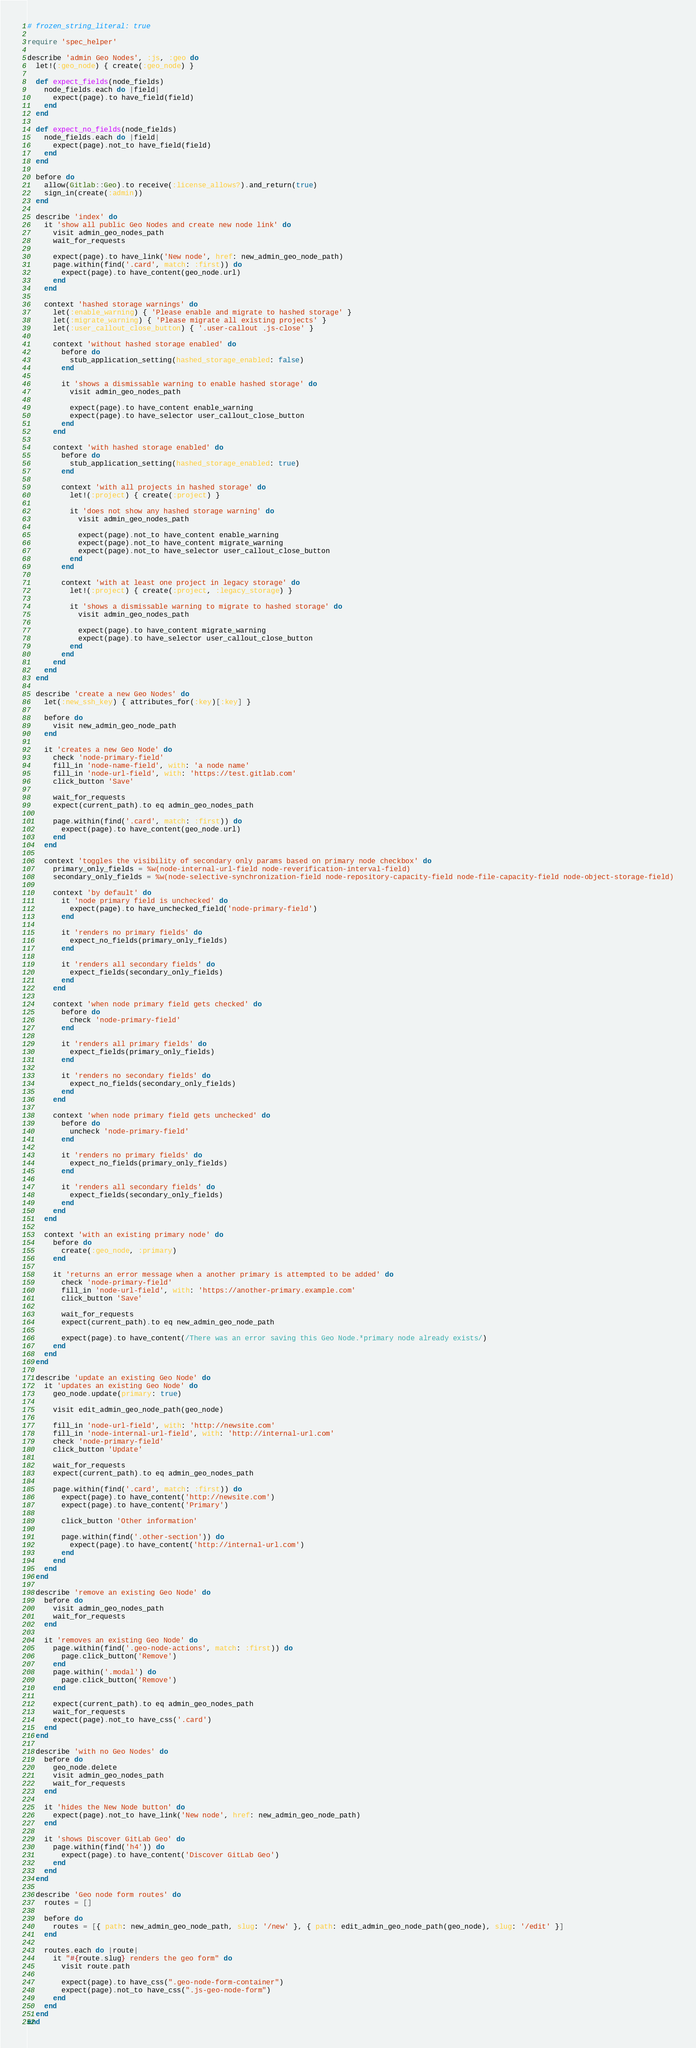Convert code to text. <code><loc_0><loc_0><loc_500><loc_500><_Ruby_># frozen_string_literal: true

require 'spec_helper'

describe 'admin Geo Nodes', :js, :geo do
  let!(:geo_node) { create(:geo_node) }

  def expect_fields(node_fields)
    node_fields.each do |field|
      expect(page).to have_field(field)
    end
  end

  def expect_no_fields(node_fields)
    node_fields.each do |field|
      expect(page).not_to have_field(field)
    end
  end

  before do
    allow(Gitlab::Geo).to receive(:license_allows?).and_return(true)
    sign_in(create(:admin))
  end

  describe 'index' do
    it 'show all public Geo Nodes and create new node link' do
      visit admin_geo_nodes_path
      wait_for_requests

      expect(page).to have_link('New node', href: new_admin_geo_node_path)
      page.within(find('.card', match: :first)) do
        expect(page).to have_content(geo_node.url)
      end
    end

    context 'hashed storage warnings' do
      let(:enable_warning) { 'Please enable and migrate to hashed storage' }
      let(:migrate_warning) { 'Please migrate all existing projects' }
      let(:user_callout_close_button) { '.user-callout .js-close' }

      context 'without hashed storage enabled' do
        before do
          stub_application_setting(hashed_storage_enabled: false)
        end

        it 'shows a dismissable warning to enable hashed storage' do
          visit admin_geo_nodes_path

          expect(page).to have_content enable_warning
          expect(page).to have_selector user_callout_close_button
        end
      end

      context 'with hashed storage enabled' do
        before do
          stub_application_setting(hashed_storage_enabled: true)
        end

        context 'with all projects in hashed storage' do
          let!(:project) { create(:project) }

          it 'does not show any hashed storage warning' do
            visit admin_geo_nodes_path

            expect(page).not_to have_content enable_warning
            expect(page).not_to have_content migrate_warning
            expect(page).not_to have_selector user_callout_close_button
          end
        end

        context 'with at least one project in legacy storage' do
          let!(:project) { create(:project, :legacy_storage) }

          it 'shows a dismissable warning to migrate to hashed storage' do
            visit admin_geo_nodes_path

            expect(page).to have_content migrate_warning
            expect(page).to have_selector user_callout_close_button
          end
        end
      end
    end
  end

  describe 'create a new Geo Nodes' do
    let(:new_ssh_key) { attributes_for(:key)[:key] }

    before do
      visit new_admin_geo_node_path
    end

    it 'creates a new Geo Node' do
      check 'node-primary-field'
      fill_in 'node-name-field', with: 'a node name'
      fill_in 'node-url-field', with: 'https://test.gitlab.com'
      click_button 'Save'

      wait_for_requests
      expect(current_path).to eq admin_geo_nodes_path

      page.within(find('.card', match: :first)) do
        expect(page).to have_content(geo_node.url)
      end
    end

    context 'toggles the visibility of secondary only params based on primary node checkbox' do
      primary_only_fields = %w(node-internal-url-field node-reverification-interval-field)
      secondary_only_fields = %w(node-selective-synchronization-field node-repository-capacity-field node-file-capacity-field node-object-storage-field)

      context 'by default' do
        it 'node primary field is unchecked' do
          expect(page).to have_unchecked_field('node-primary-field')
        end

        it 'renders no primary fields' do
          expect_no_fields(primary_only_fields)
        end

        it 'renders all secondary fields' do
          expect_fields(secondary_only_fields)
        end
      end

      context 'when node primary field gets checked' do
        before do
          check 'node-primary-field'
        end

        it 'renders all primary fields' do
          expect_fields(primary_only_fields)
        end

        it 'renders no secondary fields' do
          expect_no_fields(secondary_only_fields)
        end
      end

      context 'when node primary field gets unchecked' do
        before do
          uncheck 'node-primary-field'
        end

        it 'renders no primary fields' do
          expect_no_fields(primary_only_fields)
        end

        it 'renders all secondary fields' do
          expect_fields(secondary_only_fields)
        end
      end
    end

    context 'with an existing primary node' do
      before do
        create(:geo_node, :primary)
      end

      it 'returns an error message when a another primary is attempted to be added' do
        check 'node-primary-field'
        fill_in 'node-url-field', with: 'https://another-primary.example.com'
        click_button 'Save'

        wait_for_requests
        expect(current_path).to eq new_admin_geo_node_path

        expect(page).to have_content(/There was an error saving this Geo Node.*primary node already exists/)
      end
    end
  end

  describe 'update an existing Geo Node' do
    it 'updates an existing Geo Node' do
      geo_node.update(primary: true)

      visit edit_admin_geo_node_path(geo_node)

      fill_in 'node-url-field', with: 'http://newsite.com'
      fill_in 'node-internal-url-field', with: 'http://internal-url.com'
      check 'node-primary-field'
      click_button 'Update'

      wait_for_requests
      expect(current_path).to eq admin_geo_nodes_path

      page.within(find('.card', match: :first)) do
        expect(page).to have_content('http://newsite.com')
        expect(page).to have_content('Primary')

        click_button 'Other information'

        page.within(find('.other-section')) do
          expect(page).to have_content('http://internal-url.com')
        end
      end
    end
  end

  describe 'remove an existing Geo Node' do
    before do
      visit admin_geo_nodes_path
      wait_for_requests
    end

    it 'removes an existing Geo Node' do
      page.within(find('.geo-node-actions', match: :first)) do
        page.click_button('Remove')
      end
      page.within('.modal') do
        page.click_button('Remove')
      end

      expect(current_path).to eq admin_geo_nodes_path
      wait_for_requests
      expect(page).not_to have_css('.card')
    end
  end

  describe 'with no Geo Nodes' do
    before do
      geo_node.delete
      visit admin_geo_nodes_path
      wait_for_requests
    end

    it 'hides the New Node button' do
      expect(page).not_to have_link('New node', href: new_admin_geo_node_path)
    end

    it 'shows Discover GitLab Geo' do
      page.within(find('h4')) do
        expect(page).to have_content('Discover GitLab Geo')
      end
    end
  end

  describe 'Geo node form routes' do
    routes = []

    before do
      routes = [{ path: new_admin_geo_node_path, slug: '/new' }, { path: edit_admin_geo_node_path(geo_node), slug: '/edit' }]
    end

    routes.each do |route|
      it "#{route.slug} renders the geo form" do
        visit route.path

        expect(page).to have_css(".geo-node-form-container")
        expect(page).not_to have_css(".js-geo-node-form")
      end
    end
  end
end
</code> 